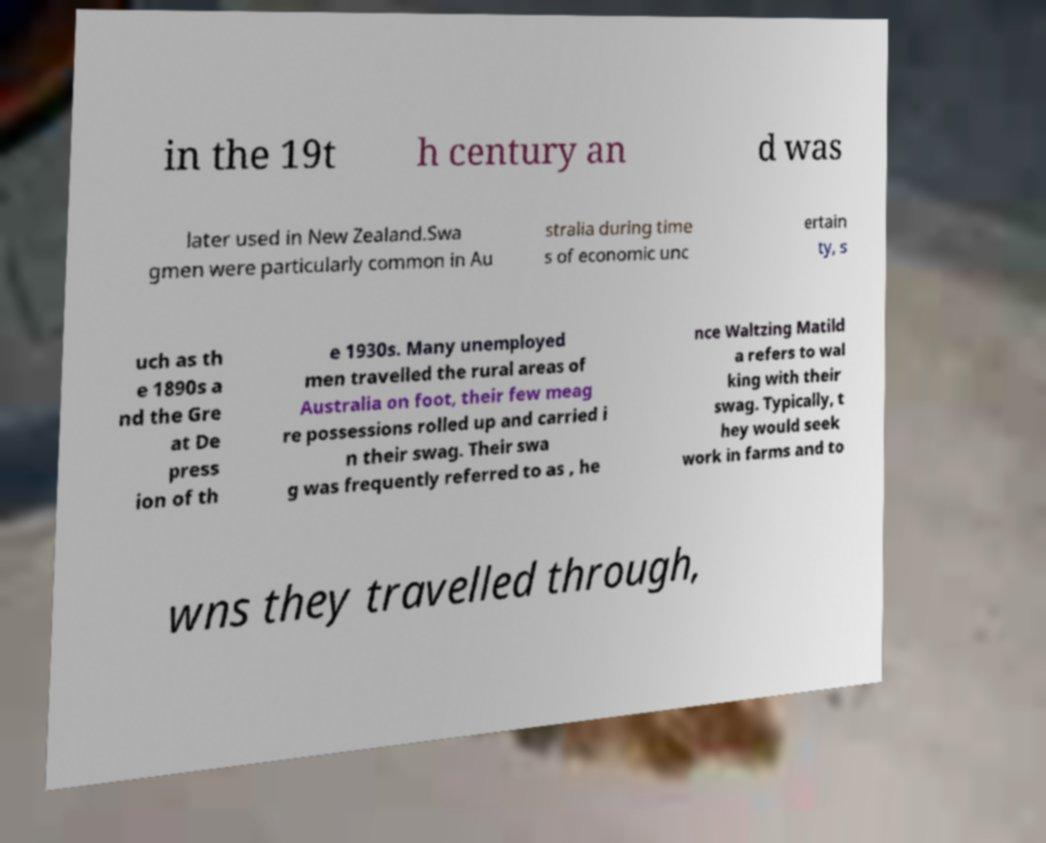Can you read and provide the text displayed in the image?This photo seems to have some interesting text. Can you extract and type it out for me? in the 19t h century an d was later used in New Zealand.Swa gmen were particularly common in Au stralia during time s of economic unc ertain ty, s uch as th e 1890s a nd the Gre at De press ion of th e 1930s. Many unemployed men travelled the rural areas of Australia on foot, their few meag re possessions rolled up and carried i n their swag. Their swa g was frequently referred to as , he nce Waltzing Matild a refers to wal king with their swag. Typically, t hey would seek work in farms and to wns they travelled through, 